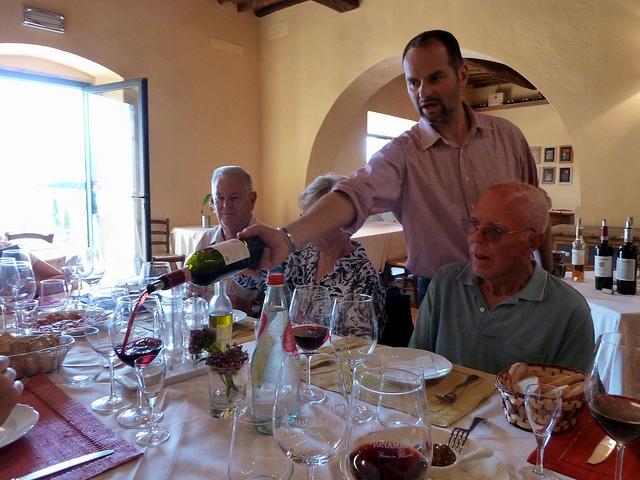What is being poured?
Concise answer only. Wine. What is the man wearing on his face?
Short answer required. Glasses. What color is the wine?
Answer briefly. Red. How many people are seated at the table?
Short answer required. 3. Are the glasses empty?
Quick response, please. No. 